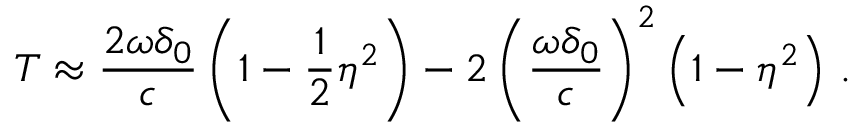<formula> <loc_0><loc_0><loc_500><loc_500>T \approx \frac { 2 \omega \delta _ { 0 } } { c } \left ( 1 - \frac { 1 } { 2 } \eta ^ { 2 } \right ) - 2 \left ( \frac { \omega \delta _ { 0 } } { c } \right ) ^ { 2 } \left ( 1 - \eta ^ { 2 } \right ) \, .</formula> 